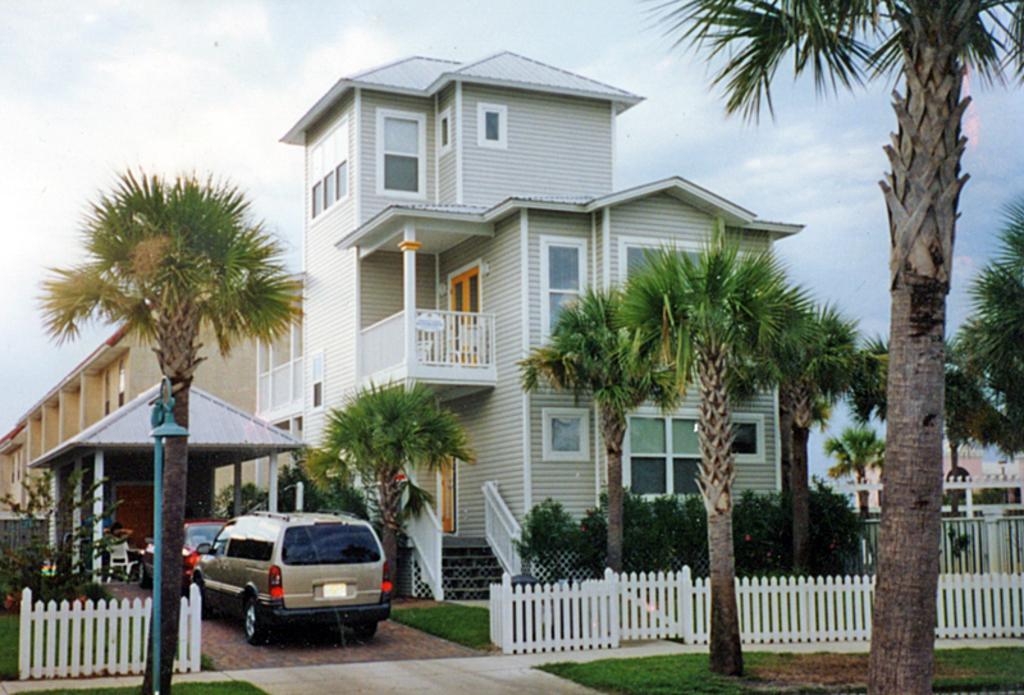Could you give a brief overview of what you see in this image? This is an outside view. In the middle of the image there are few buildings. In the foreground there are some trees. In front of this building there are some plants and also there is a fencing. On the left side there is a shed. Under the shed a person is sitting on a chair and there are two cars. At the bottom, I can see the grass on the ground. At the top of the image I can see the sky. 